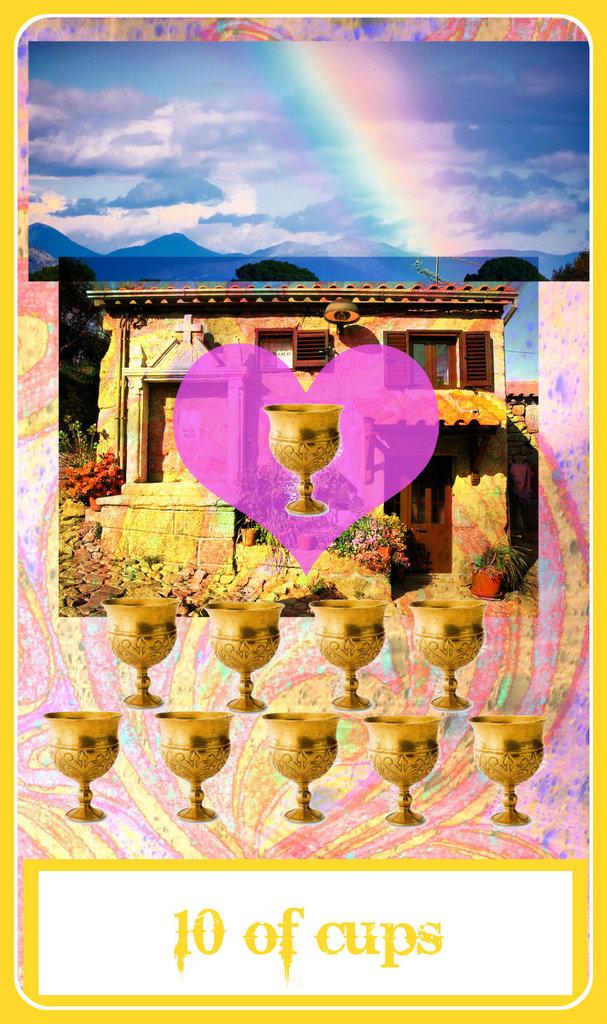What is the card a 10 of?
Offer a very short reply. Cups. How many cups?
Your answer should be very brief. 10. 